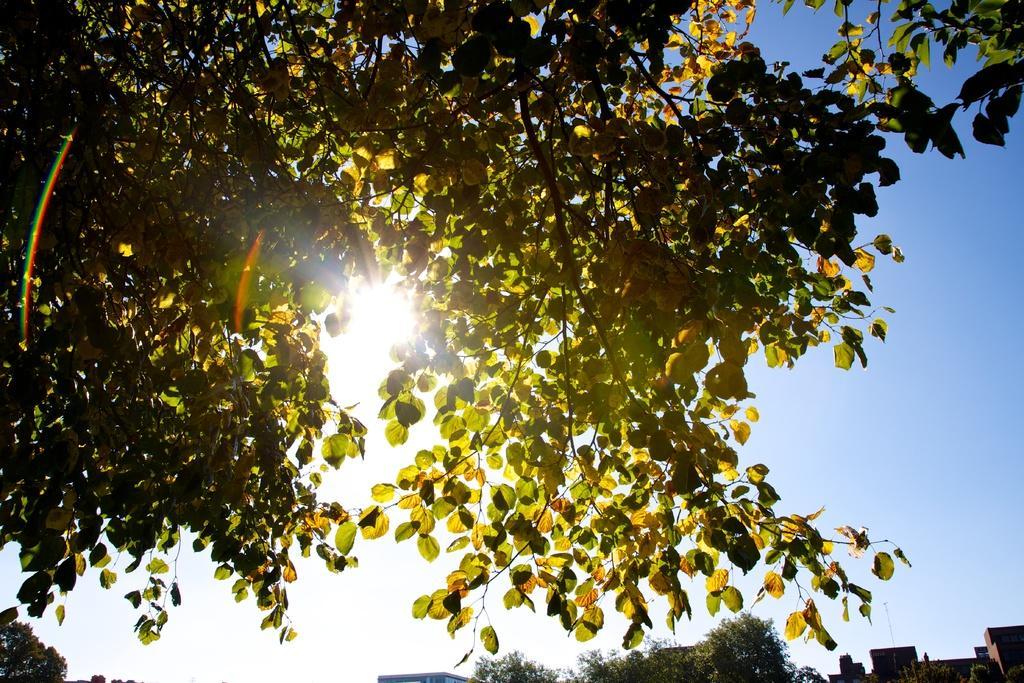In one or two sentences, can you explain what this image depicts? In this image we can see tree. Behind the tree sky and sun is there. Bottom of the image trees and buildings are there. 